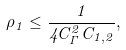<formula> <loc_0><loc_0><loc_500><loc_500>\rho _ { 1 } \leq \frac { 1 } { 4 C _ { \Gamma } ^ { 2 } C _ { 1 , 2 } } ,</formula> 